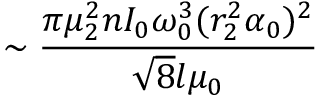Convert formula to latex. <formula><loc_0><loc_0><loc_500><loc_500>\sim \frac { \pi \mu _ { 2 } ^ { 2 } n I _ { 0 } \omega _ { 0 } ^ { 3 } ( r _ { 2 } ^ { 2 } \alpha _ { 0 } ) ^ { 2 } } { \sqrt { 8 } l \mu _ { 0 } }</formula> 